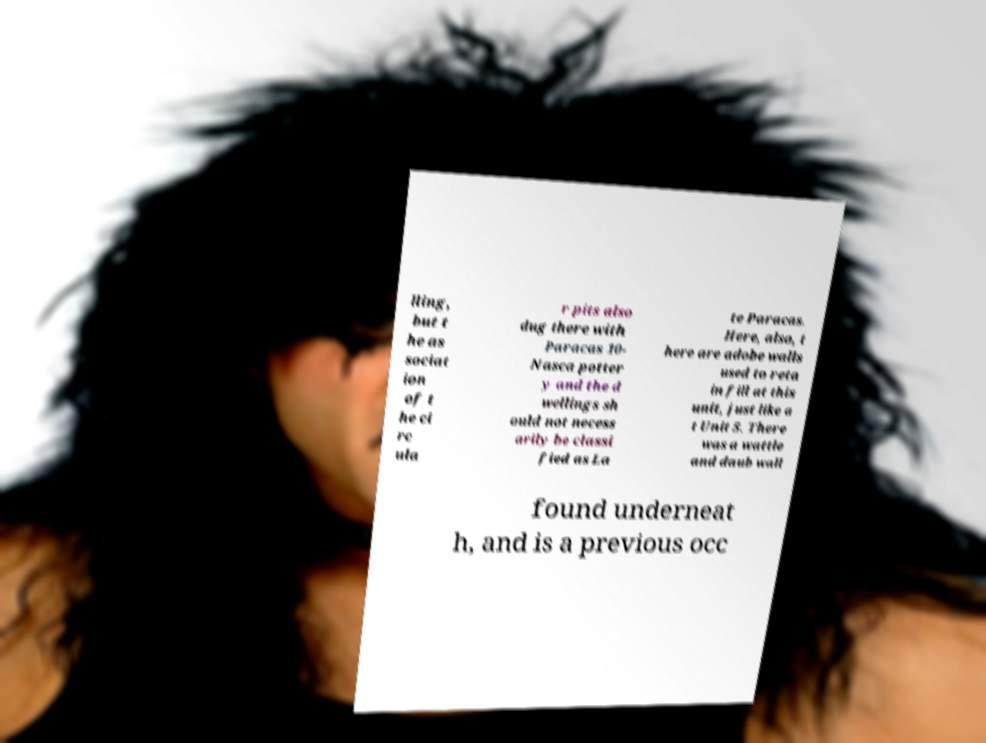Can you accurately transcribe the text from the provided image for me? lling, but t he as sociat ion of t he ci rc ula r pits also dug there with Paracas 10- Nasca potter y and the d wellings sh ould not necess arily be classi fied as La te Paracas. Here, also, t here are adobe walls used to reta in fill at this unit, just like a t Unit 5. There was a wattle and daub wall found underneat h, and is a previous occ 